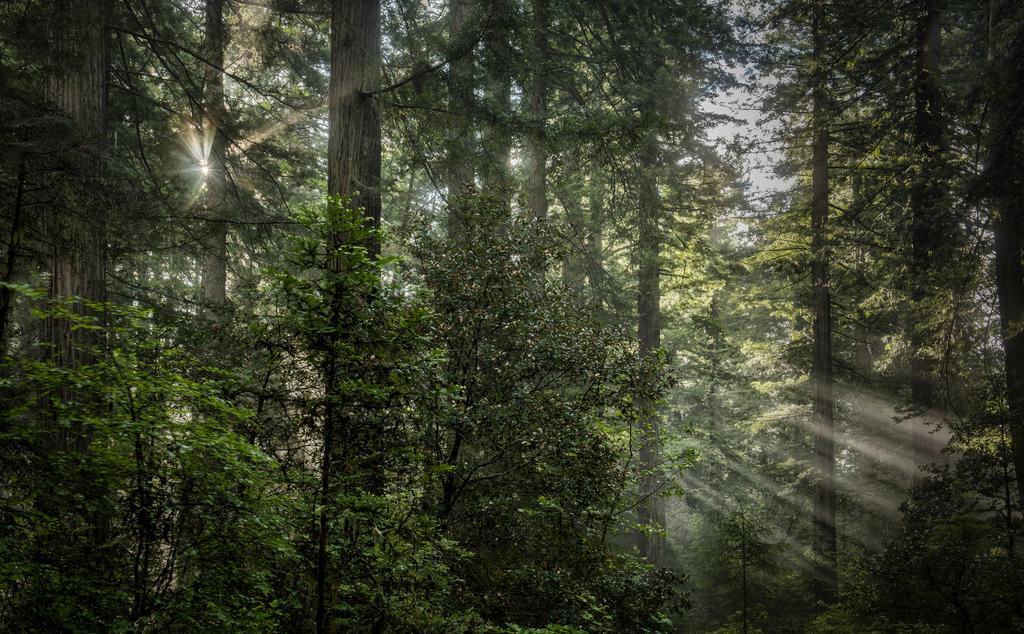Could you give a brief overview of what you see in this image? In this image there are trees. 